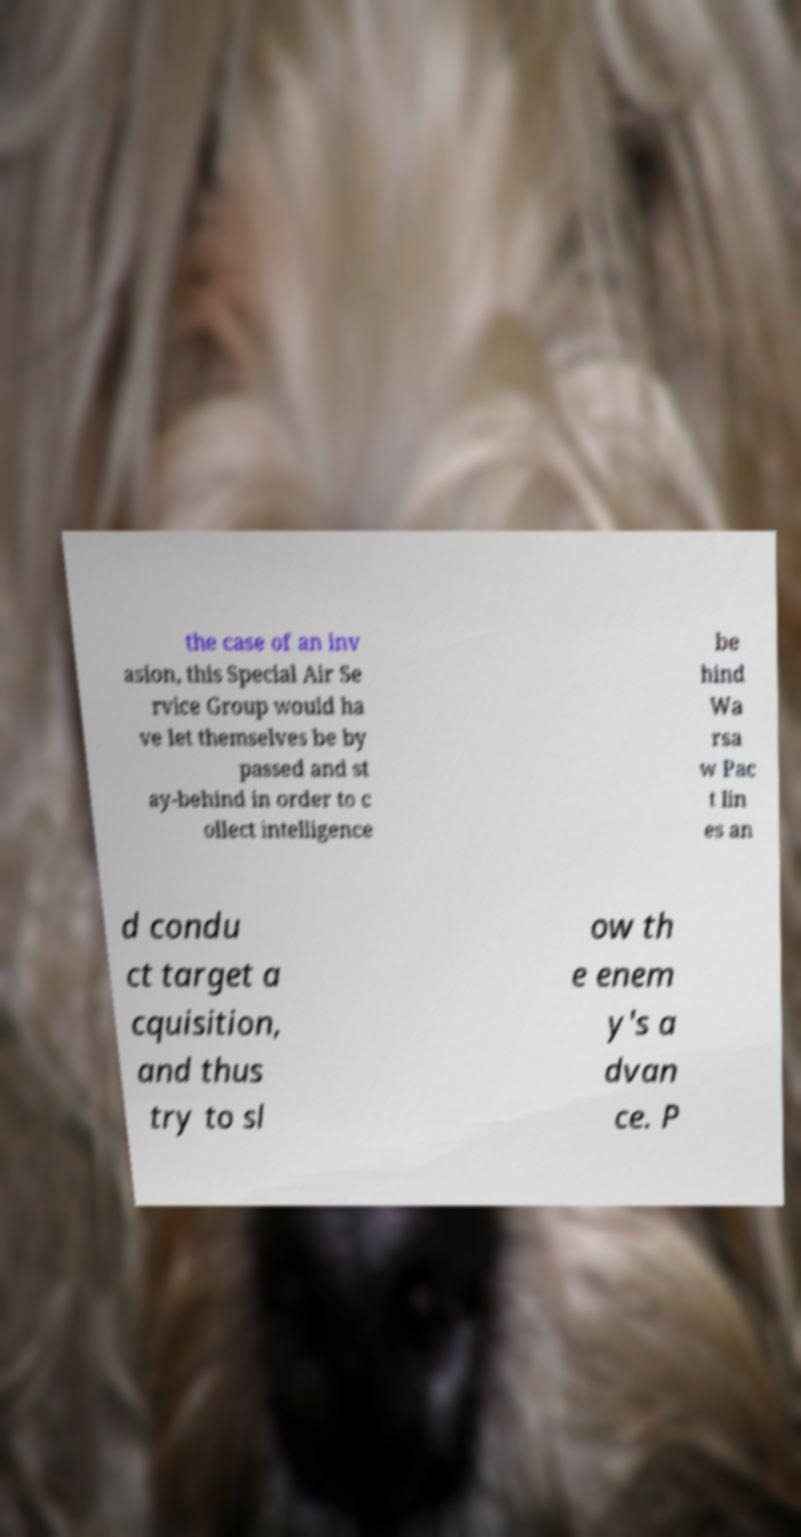Can you read and provide the text displayed in the image?This photo seems to have some interesting text. Can you extract and type it out for me? the case of an inv asion, this Special Air Se rvice Group would ha ve let themselves be by passed and st ay-behind in order to c ollect intelligence be hind Wa rsa w Pac t lin es an d condu ct target a cquisition, and thus try to sl ow th e enem y's a dvan ce. P 